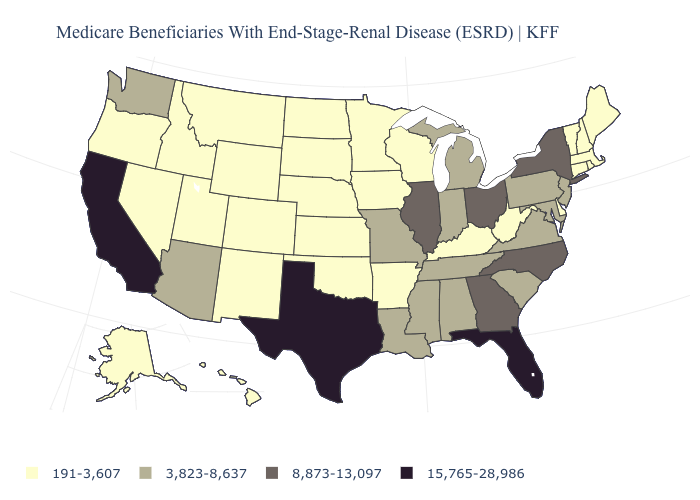Does Hawaii have the lowest value in the West?
Keep it brief. Yes. Name the states that have a value in the range 191-3,607?
Be succinct. Alaska, Arkansas, Colorado, Connecticut, Delaware, Hawaii, Idaho, Iowa, Kansas, Kentucky, Maine, Massachusetts, Minnesota, Montana, Nebraska, Nevada, New Hampshire, New Mexico, North Dakota, Oklahoma, Oregon, Rhode Island, South Dakota, Utah, Vermont, West Virginia, Wisconsin, Wyoming. What is the value of Colorado?
Short answer required. 191-3,607. Does California have the lowest value in the West?
Be succinct. No. Name the states that have a value in the range 3,823-8,637?
Answer briefly. Alabama, Arizona, Indiana, Louisiana, Maryland, Michigan, Mississippi, Missouri, New Jersey, Pennsylvania, South Carolina, Tennessee, Virginia, Washington. What is the value of Arizona?
Short answer required. 3,823-8,637. Does the map have missing data?
Write a very short answer. No. What is the value of Indiana?
Quick response, please. 3,823-8,637. Does Florida have the lowest value in the USA?
Be succinct. No. What is the highest value in states that border Maryland?
Write a very short answer. 3,823-8,637. Does Missouri have the lowest value in the USA?
Quick response, please. No. Among the states that border Massachusetts , which have the lowest value?
Keep it brief. Connecticut, New Hampshire, Rhode Island, Vermont. Which states have the highest value in the USA?
Quick response, please. California, Florida, Texas. Does the first symbol in the legend represent the smallest category?
Be succinct. Yes. Does the map have missing data?
Write a very short answer. No. 